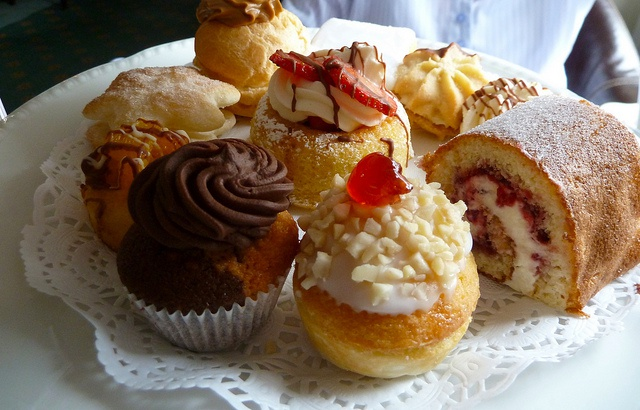Describe the objects in this image and their specific colors. I can see cake in black, brown, gray, maroon, and lightgray tones, cake in black, olive, maroon, and tan tones, cake in black, maroon, and gray tones, cake in black, maroon, brown, and gray tones, and people in black, lavender, gray, and darkgray tones in this image. 